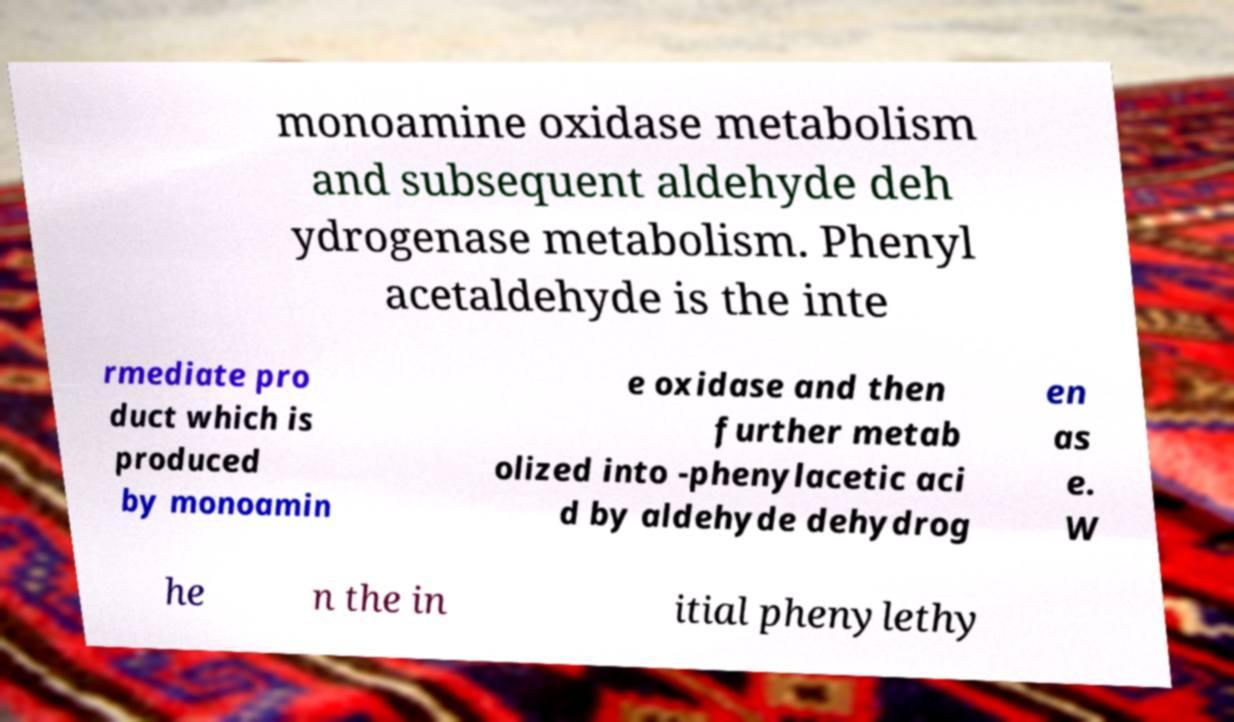There's text embedded in this image that I need extracted. Can you transcribe it verbatim? monoamine oxidase metabolism and subsequent aldehyde deh ydrogenase metabolism. Phenyl acetaldehyde is the inte rmediate pro duct which is produced by monoamin e oxidase and then further metab olized into -phenylacetic aci d by aldehyde dehydrog en as e. W he n the in itial phenylethy 